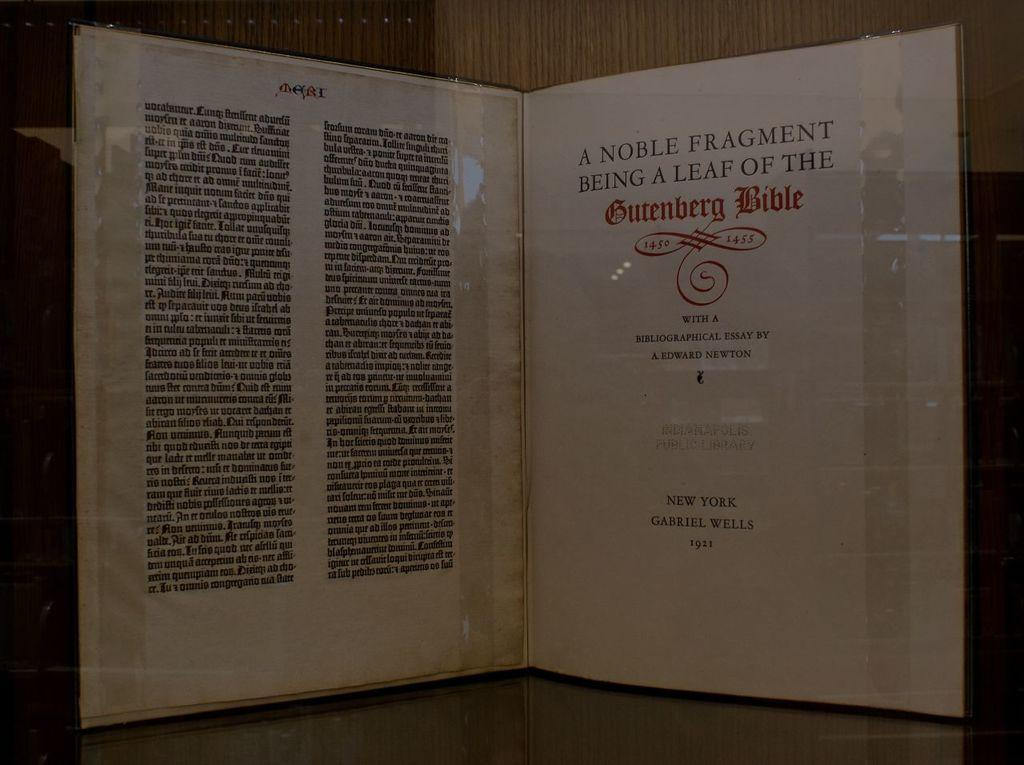Provide a one-sentence caption for the provided image. A book is displayed showing a page about the Gutenberg Bible. 